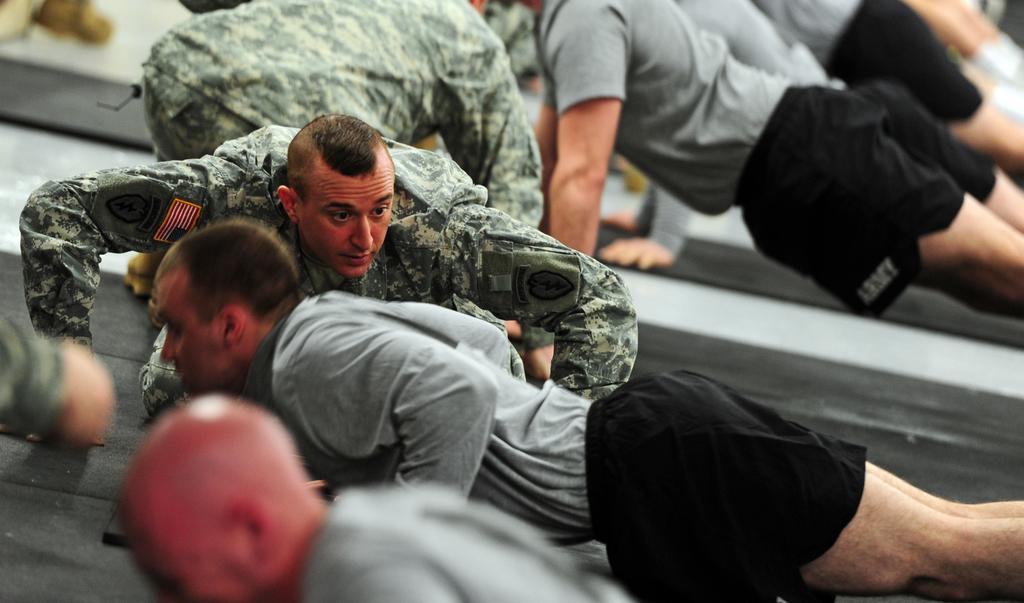Please provide a concise description of this image. In this image we can see group of persons on the ground. Some persons are wearing military uniforms. 